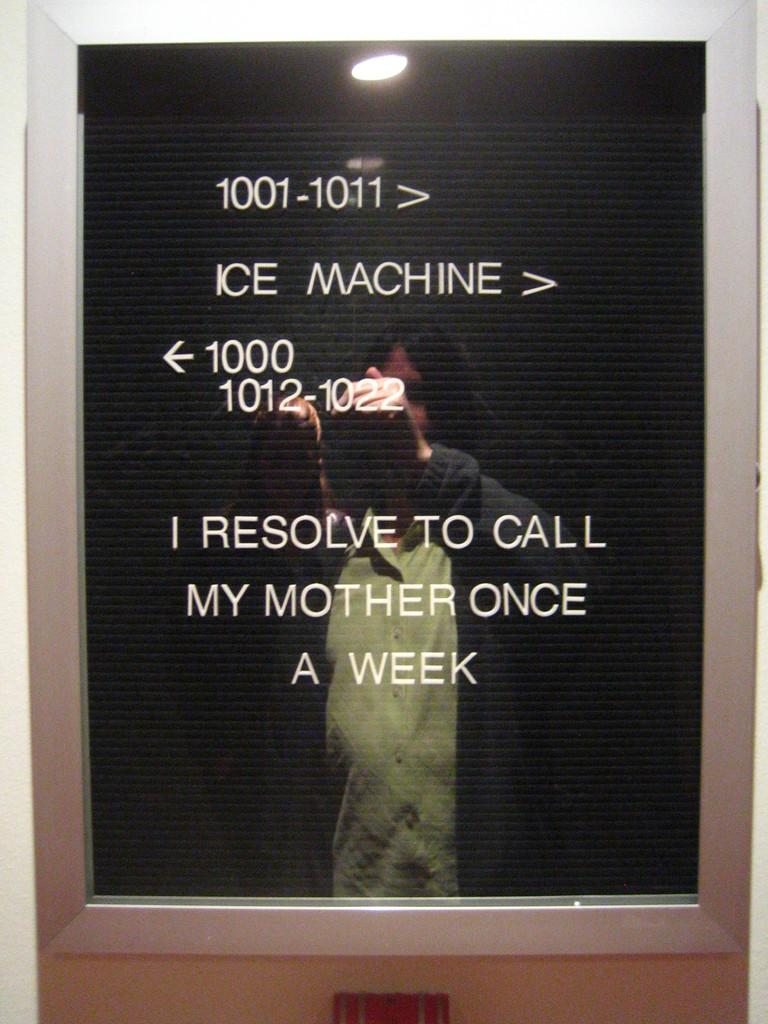<image>
Provide a brief description of the given image. A sign directing hotel patrons to the ice machine. 